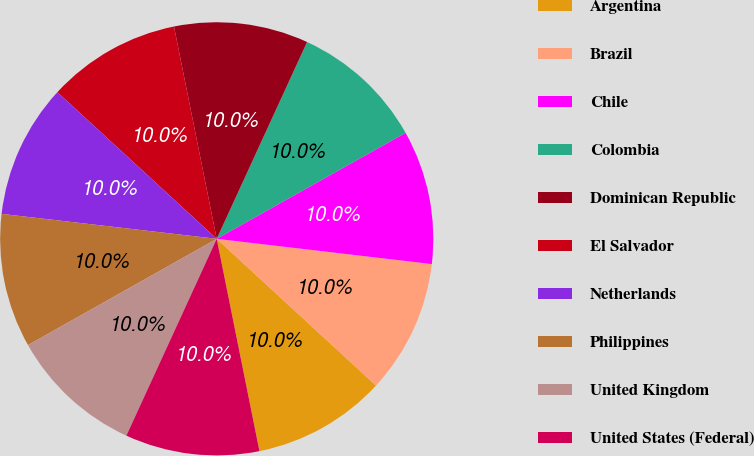Convert chart. <chart><loc_0><loc_0><loc_500><loc_500><pie_chart><fcel>Argentina<fcel>Brazil<fcel>Chile<fcel>Colombia<fcel>Dominican Republic<fcel>El Salvador<fcel>Netherlands<fcel>Philippines<fcel>United Kingdom<fcel>United States (Federal)<nl><fcel>9.99%<fcel>9.99%<fcel>10.0%<fcel>10.01%<fcel>10.01%<fcel>10.0%<fcel>10.0%<fcel>10.0%<fcel>9.99%<fcel>10.01%<nl></chart> 